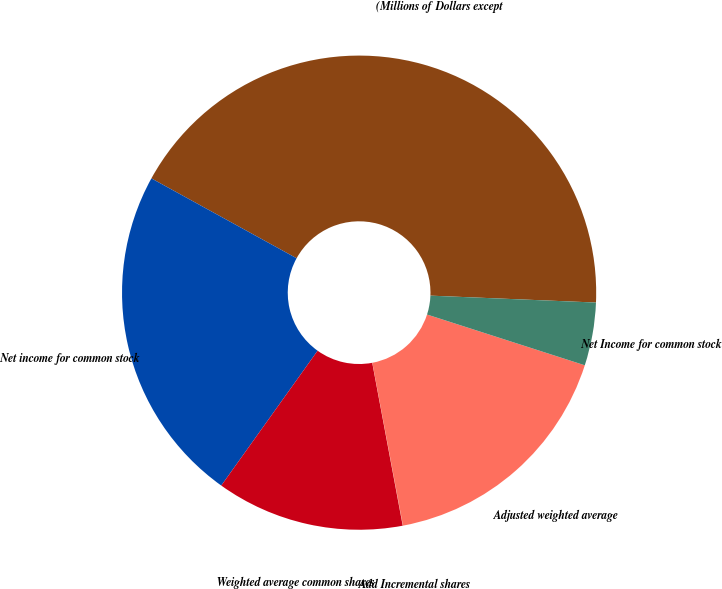<chart> <loc_0><loc_0><loc_500><loc_500><pie_chart><fcel>(Millions of Dollars except<fcel>Net income for common stock<fcel>Weighted average common shares<fcel>Add Incremental shares<fcel>Adjusted weighted average<fcel>Net Income for common stock<nl><fcel>42.66%<fcel>23.13%<fcel>12.82%<fcel>0.02%<fcel>17.08%<fcel>4.29%<nl></chart> 